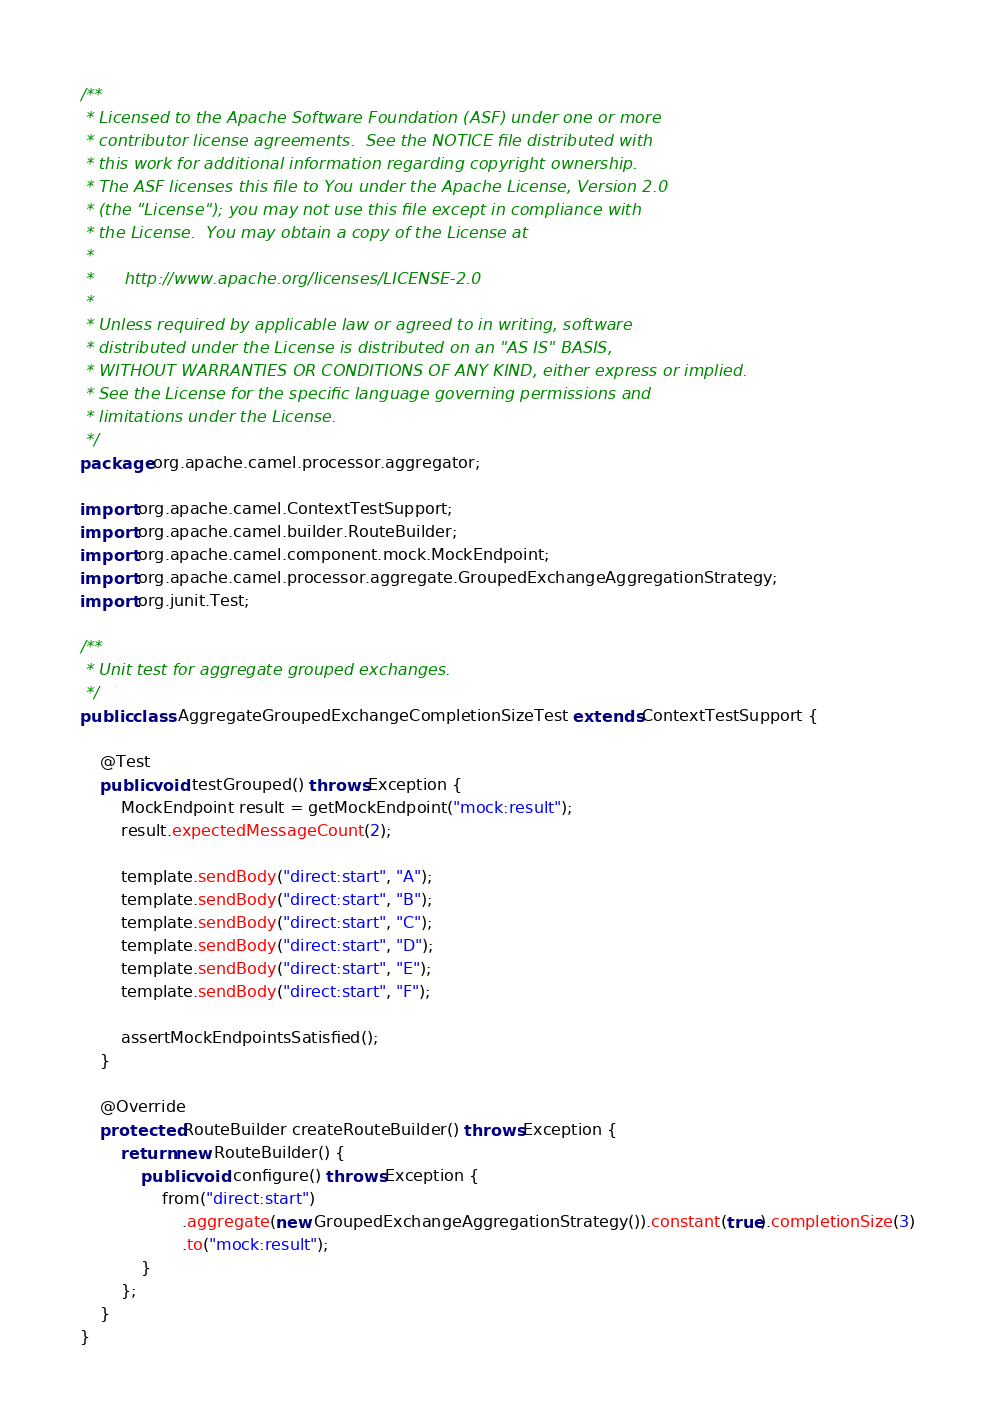<code> <loc_0><loc_0><loc_500><loc_500><_Java_>/**
 * Licensed to the Apache Software Foundation (ASF) under one or more
 * contributor license agreements.  See the NOTICE file distributed with
 * this work for additional information regarding copyright ownership.
 * The ASF licenses this file to You under the Apache License, Version 2.0
 * (the "License"); you may not use this file except in compliance with
 * the License.  You may obtain a copy of the License at
 *
 *      http://www.apache.org/licenses/LICENSE-2.0
 *
 * Unless required by applicable law or agreed to in writing, software
 * distributed under the License is distributed on an "AS IS" BASIS,
 * WITHOUT WARRANTIES OR CONDITIONS OF ANY KIND, either express or implied.
 * See the License for the specific language governing permissions and
 * limitations under the License.
 */
package org.apache.camel.processor.aggregator;

import org.apache.camel.ContextTestSupport;
import org.apache.camel.builder.RouteBuilder;
import org.apache.camel.component.mock.MockEndpoint;
import org.apache.camel.processor.aggregate.GroupedExchangeAggregationStrategy;
import org.junit.Test;

/**
 * Unit test for aggregate grouped exchanges.
 */
public class AggregateGroupedExchangeCompletionSizeTest extends ContextTestSupport {

    @Test
    public void testGrouped() throws Exception {
        MockEndpoint result = getMockEndpoint("mock:result");
        result.expectedMessageCount(2);

        template.sendBody("direct:start", "A");
        template.sendBody("direct:start", "B");
        template.sendBody("direct:start", "C");
        template.sendBody("direct:start", "D");
        template.sendBody("direct:start", "E");
        template.sendBody("direct:start", "F");

        assertMockEndpointsSatisfied();
    }

    @Override
    protected RouteBuilder createRouteBuilder() throws Exception {
        return new RouteBuilder() {
            public void configure() throws Exception {
                from("direct:start")
                    .aggregate(new GroupedExchangeAggregationStrategy()).constant(true).completionSize(3)
                    .to("mock:result");
            }
        };
    }
}</code> 